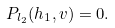<formula> <loc_0><loc_0><loc_500><loc_500>P _ { l _ { 2 } } ( h _ { 1 } , v ) = 0 .</formula> 